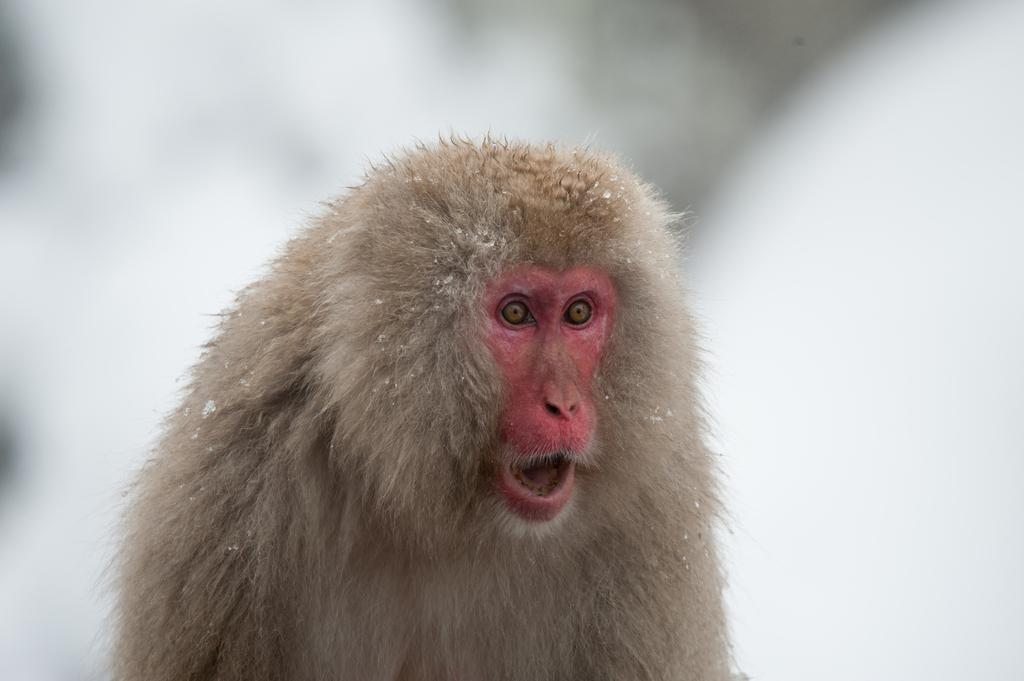What is the main subject of the image? There is a monkey in the middle of the image. What color is the background of the image? The background of the image is white. What type of mask is the monkey wearing in the image? There is no mask present in the image; the monkey is not wearing any mask. What is the monkey's belief system in the image? The image does not provide any information about the monkey's belief system. --- Facts: 1. There is a car in the image. 2. The car is red. 3. The car has four wheels. 4. There is a road in the image. 5. The road is paved. Absurd Topics: dance, ocean, birdhouse Conversation: What is the main subject of the image? There is a car in the image. What color is the car? The car is red. How many wheels does the car have? The car has four wheels. What type of surface is the car on in the image? There is a road in the image, and it is paved. Reasoning: Let's think step by step in order to produce the conversation. We start by identifying the main subject of the image, which is the car. Then, we describe the car's color and the number of wheels it has. Next, we mention the road and its paved surface. We avoid yes/no questions and ensure that the language is simple and clear. Absurd Question/Answer: Can you see any birds dancing near the ocean in the image? There is no ocean or dancing birds present in the image; it features a red car on a paved road. Is there a birdhouse on the car in the image? There is no birdhouse present on the car in the image. 